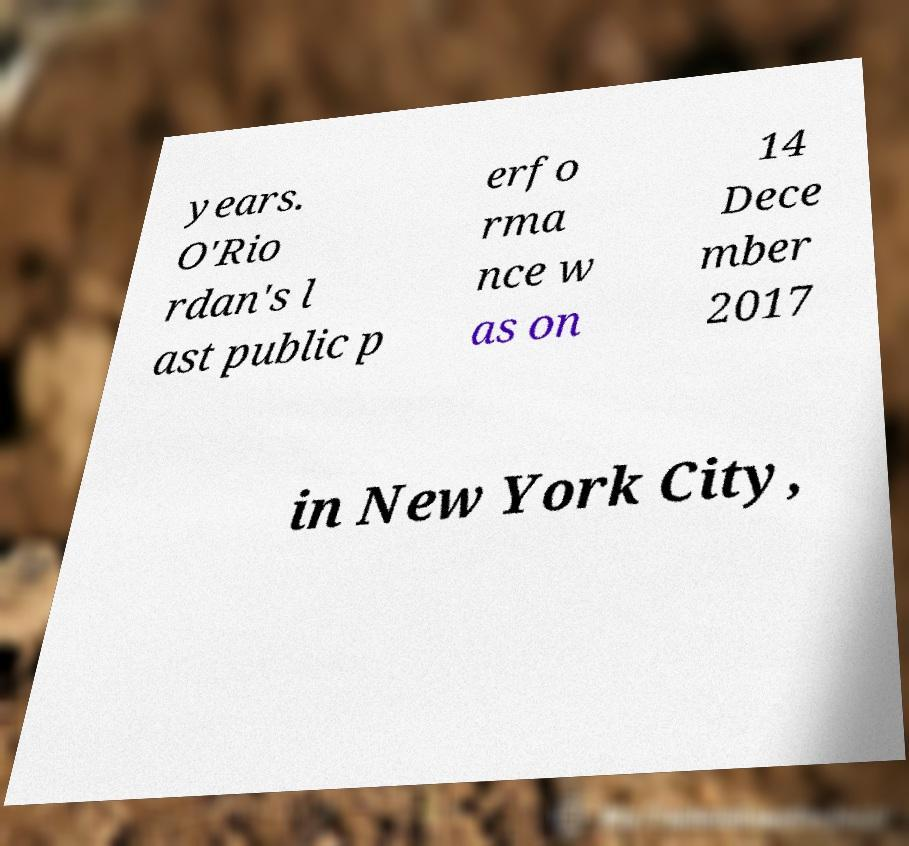I need the written content from this picture converted into text. Can you do that? years. O'Rio rdan's l ast public p erfo rma nce w as on 14 Dece mber 2017 in New York City, 